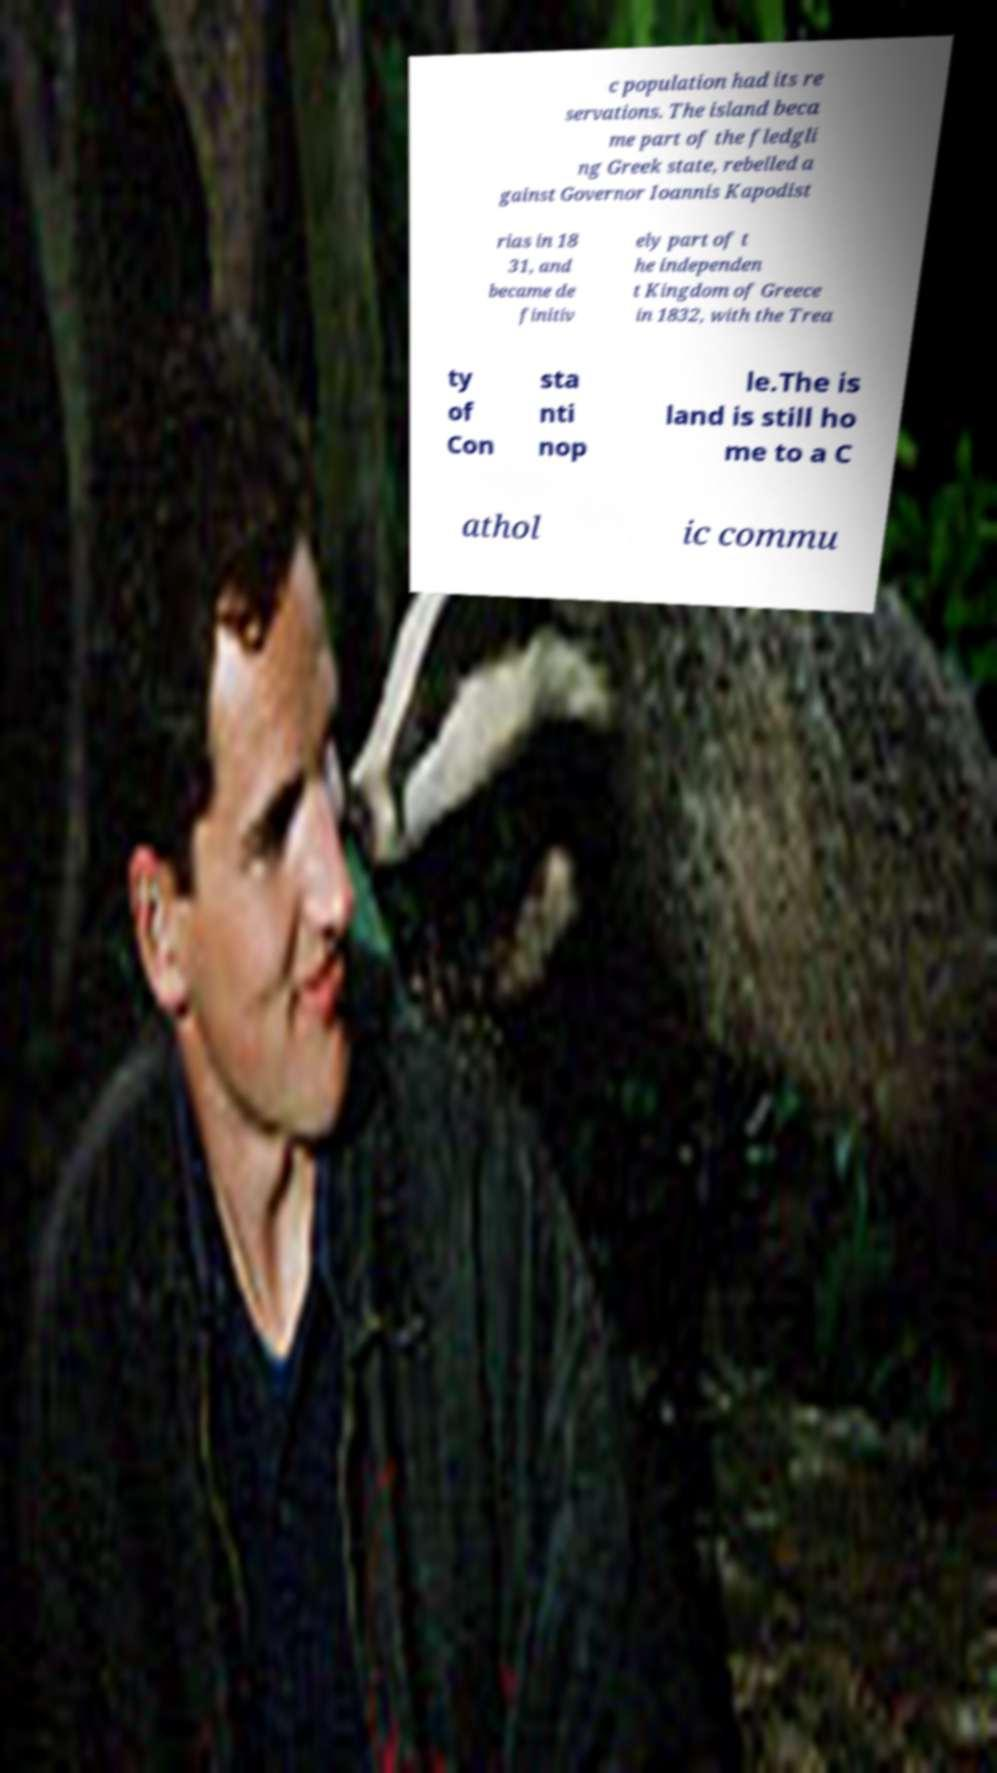What messages or text are displayed in this image? I need them in a readable, typed format. c population had its re servations. The island beca me part of the fledgli ng Greek state, rebelled a gainst Governor Ioannis Kapodist rias in 18 31, and became de finitiv ely part of t he independen t Kingdom of Greece in 1832, with the Trea ty of Con sta nti nop le.The is land is still ho me to a C athol ic commu 